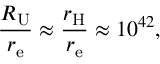<formula> <loc_0><loc_0><loc_500><loc_500>{ \frac { R _ { U } } { r _ { e } } } \approx { \frac { r _ { H } } { r _ { e } } } \approx 1 0 ^ { 4 2 } ,</formula> 